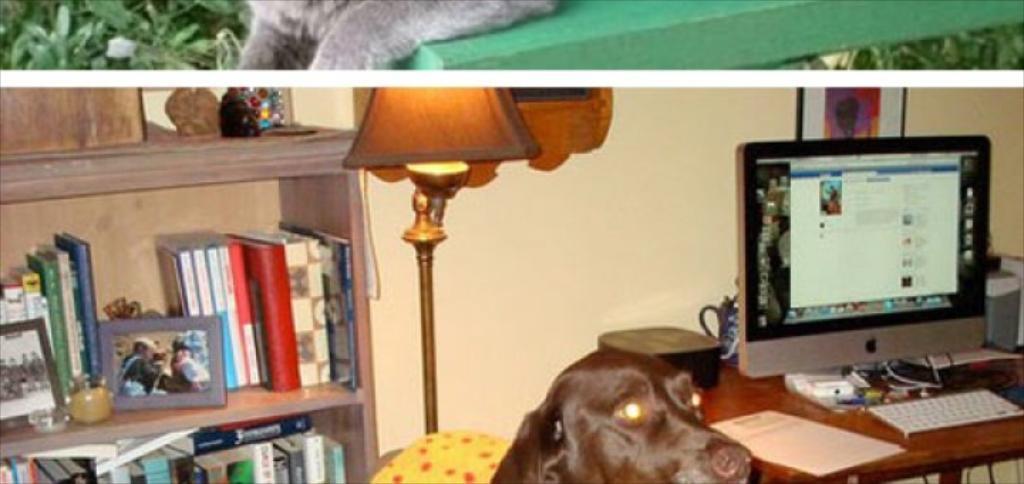Please provide a concise description of this image. In this image, in the right side there is a table which is in brown color, on that table there is a monitor and there is a keyboard which is in white color, there are some papers which are white color, in the middle there is a dog which is in black color standing, there is a lamp which is in brown color, in the left side there are some books kept in the rack, in the background there is a yellow color wall. 